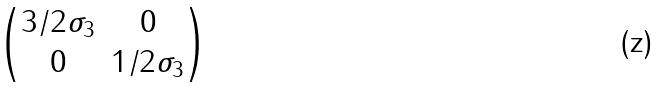<formula> <loc_0><loc_0><loc_500><loc_500>\begin{pmatrix} 3 / 2 \sigma _ { 3 } & 0 \\ 0 & 1 / 2 \sigma _ { 3 } \\ \end{pmatrix}</formula> 